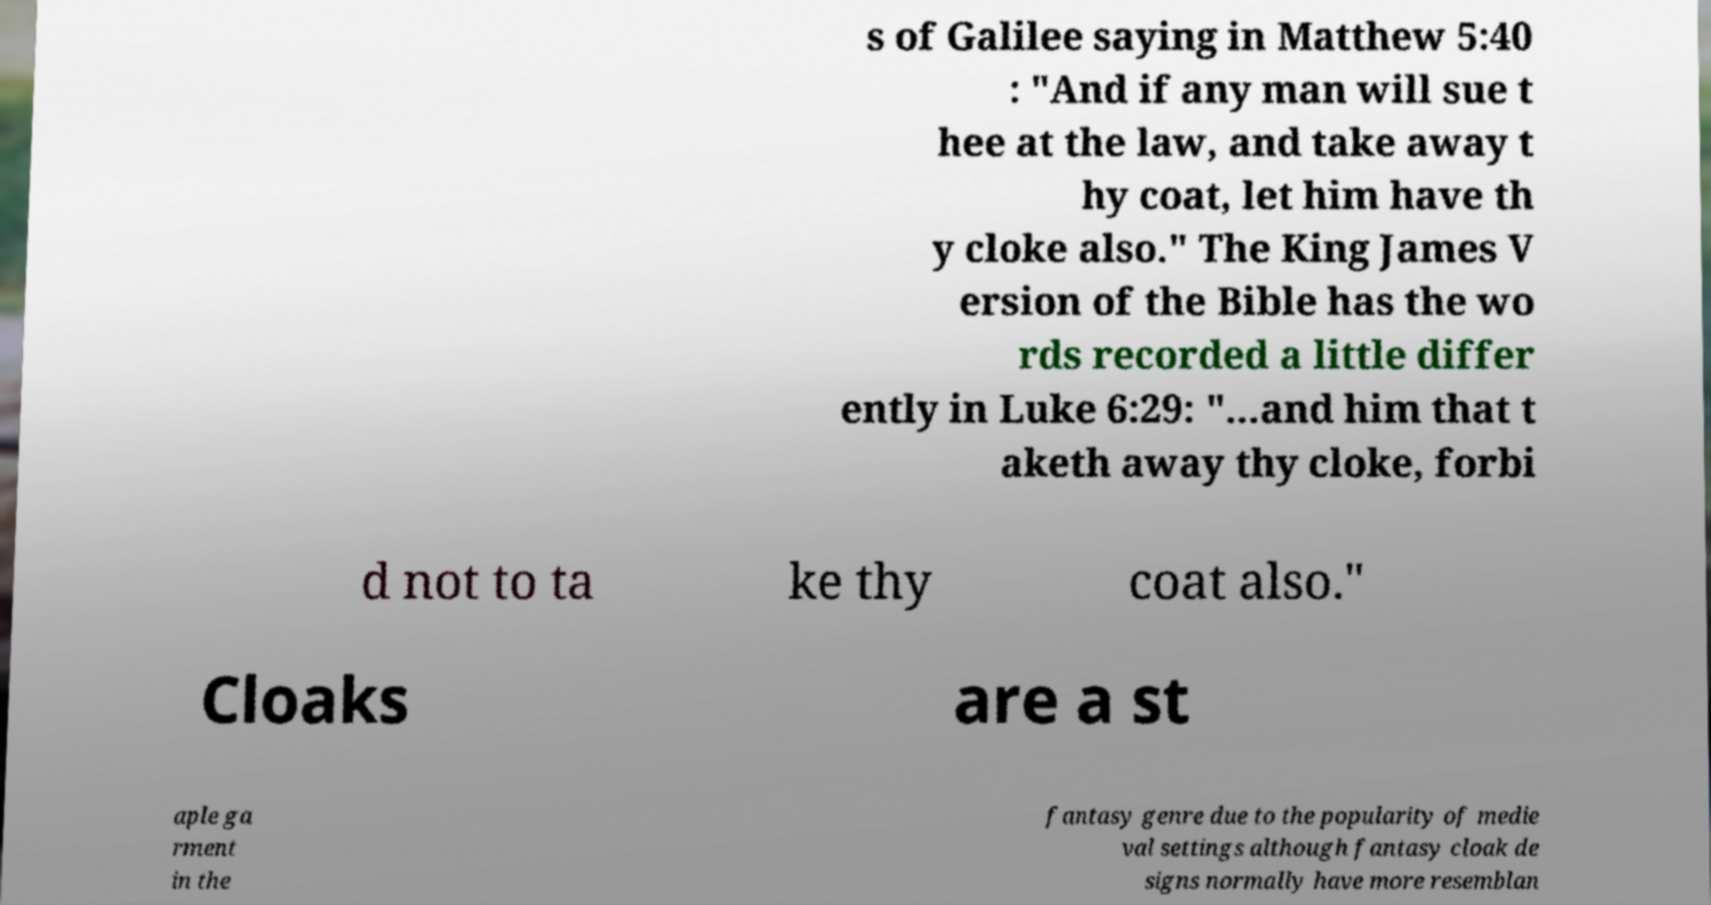There's text embedded in this image that I need extracted. Can you transcribe it verbatim? s of Galilee saying in Matthew 5:40 : "And if any man will sue t hee at the law, and take away t hy coat, let him have th y cloke also." The King James V ersion of the Bible has the wo rds recorded a little differ ently in Luke 6:29: "...and him that t aketh away thy cloke, forbi d not to ta ke thy coat also." Cloaks are a st aple ga rment in the fantasy genre due to the popularity of medie val settings although fantasy cloak de signs normally have more resemblan 